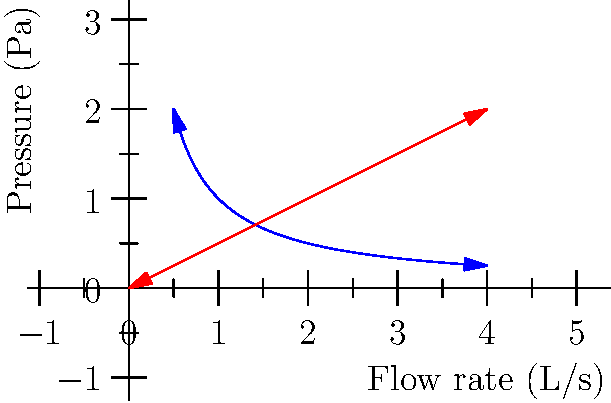In a plant-based milk packaging facility, you observe that almond milk and oat milk behave differently when flowing through the same machinery. The graph shows the relationship between flow rate and pressure for both types of milk. Based on this information, which type of milk is more likely to cause clogging issues in the packaging machinery, and why? To determine which milk is more likely to cause clogging, we need to analyze the relationship between flow rate and pressure for each milk:

1. Almond milk (blue curve):
   - The curve follows an inverse relationship: $P = \frac{k}{Q}$, where $P$ is pressure, $Q$ is flow rate, and $k$ is a constant.
   - As flow rate increases, pressure decreases rapidly.

2. Oat milk (red line):
   - The relationship is linear: $P = mQ$, where $m$ is the slope.
   - As flow rate increases, pressure increases proportionally.

3. Clogging tendency:
   - Clogging is more likely to occur when pressure increases rapidly with small changes in flow rate.
   - For almond milk, at low flow rates, small decreases in flow cause large increases in pressure.
   - For oat milk, pressure changes are more gradual and predictable.

4. Fluid dynamics interpretation:
   - Almond milk exhibits non-Newtonian behavior, typical of fluids with suspended particles.
   - Oat milk behaves more like a Newtonian fluid, with a constant viscosity.

5. Conclusion:
   - Almond milk is more likely to cause clogging issues due to its rapid pressure changes at low flow rates, which can lead to particle aggregation and blockages in narrow passages of the machinery.
Answer: Almond milk, due to its non-Newtonian behavior and rapid pressure increases at low flow rates. 